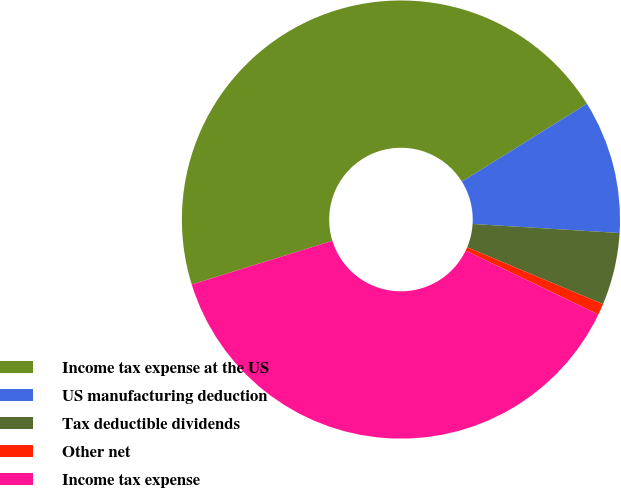<chart> <loc_0><loc_0><loc_500><loc_500><pie_chart><fcel>Income tax expense at the US<fcel>US manufacturing deduction<fcel>Tax deductible dividends<fcel>Other net<fcel>Income tax expense<nl><fcel>45.93%<fcel>9.84%<fcel>5.33%<fcel>0.82%<fcel>38.07%<nl></chart> 